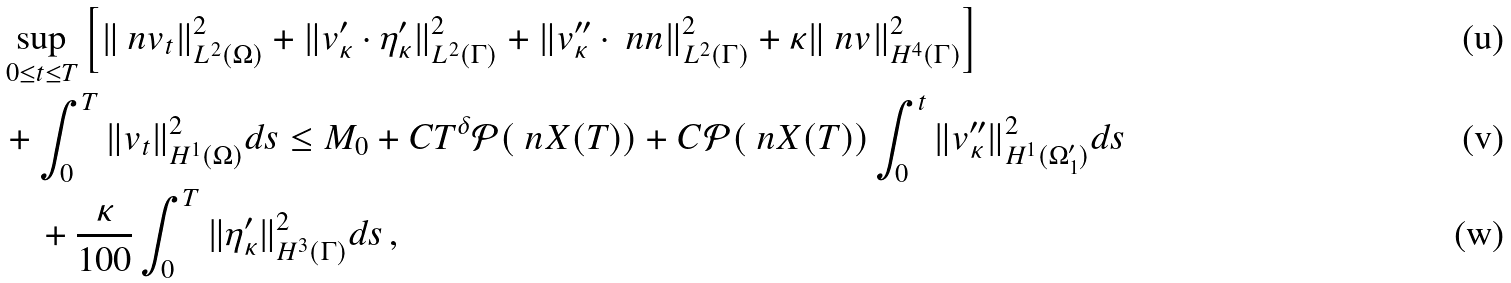<formula> <loc_0><loc_0><loc_500><loc_500>& \sup _ { 0 \leq t \leq T } \left [ \| \ n v _ { t } \| ^ { 2 } _ { L ^ { 2 } ( \Omega ) } + \| v _ { \kappa } ^ { \prime } \cdot \eta _ { \kappa } ^ { \prime } \| ^ { 2 } _ { L ^ { 2 } ( \Gamma ) } + \| v _ { \kappa } ^ { \prime \prime } \cdot \ n n \| ^ { 2 } _ { L ^ { 2 } ( \Gamma ) } + \kappa \| \ n v \| ^ { 2 } _ { H ^ { 4 } ( \Gamma ) } \right ] \\ & + \int _ { 0 } ^ { T } \| v _ { t } \| ^ { 2 } _ { H ^ { 1 } ( \Omega ) } d s \leq M _ { 0 } + C T ^ { \delta } { \mathcal { P } } ( \ n X ( T ) ) + C { \mathcal { P } } ( \ n X ( T ) ) \int _ { 0 } ^ { t } \| v _ { \kappa } ^ { \prime \prime } \| ^ { 2 } _ { H ^ { 1 } ( \Omega _ { 1 } ^ { \prime } ) } d s \\ & \quad + \frac { \kappa } { 1 0 0 } \int _ { 0 } ^ { T } \| \eta _ { \kappa } ^ { \prime } \| ^ { 2 } _ { H ^ { 3 } ( \Gamma ) } d s \, ,</formula> 